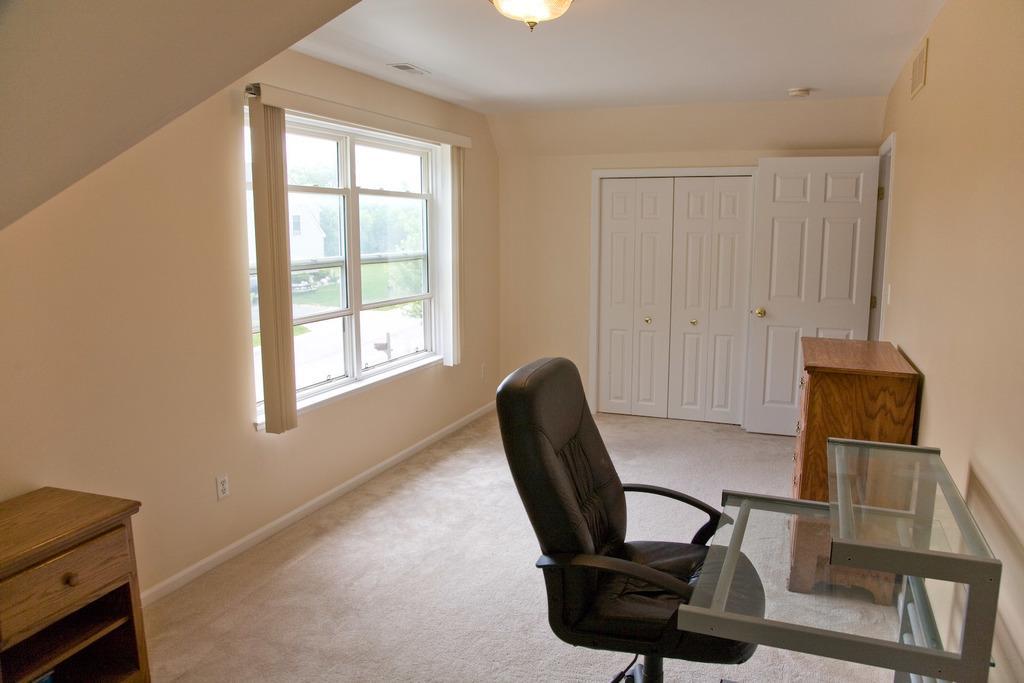Could you give a brief overview of what you see in this image? In this picture we can see a room with windows, curtain, door, cupboard, chair, table, floor, light, wall. 